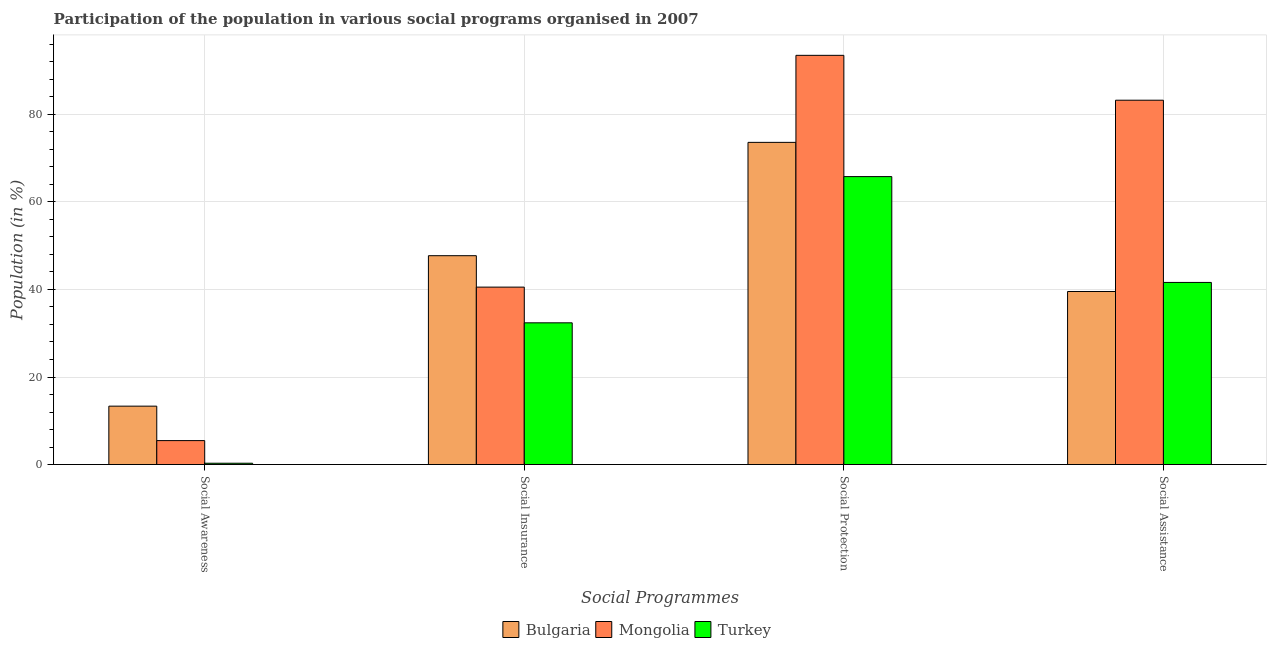How many different coloured bars are there?
Keep it short and to the point. 3. How many groups of bars are there?
Offer a very short reply. 4. Are the number of bars per tick equal to the number of legend labels?
Make the answer very short. Yes. Are the number of bars on each tick of the X-axis equal?
Provide a short and direct response. Yes. How many bars are there on the 2nd tick from the left?
Offer a terse response. 3. What is the label of the 1st group of bars from the left?
Your answer should be compact. Social Awareness. What is the participation of population in social awareness programs in Mongolia?
Ensure brevity in your answer.  5.47. Across all countries, what is the maximum participation of population in social protection programs?
Ensure brevity in your answer.  93.49. Across all countries, what is the minimum participation of population in social protection programs?
Keep it short and to the point. 65.79. What is the total participation of population in social protection programs in the graph?
Make the answer very short. 232.89. What is the difference between the participation of population in social assistance programs in Bulgaria and that in Mongolia?
Your answer should be very brief. -43.7. What is the difference between the participation of population in social assistance programs in Bulgaria and the participation of population in social protection programs in Mongolia?
Provide a short and direct response. -53.96. What is the average participation of population in social protection programs per country?
Give a very brief answer. 77.63. What is the difference between the participation of population in social protection programs and participation of population in social insurance programs in Turkey?
Keep it short and to the point. 33.41. In how many countries, is the participation of population in social awareness programs greater than 80 %?
Ensure brevity in your answer.  0. What is the ratio of the participation of population in social awareness programs in Turkey to that in Bulgaria?
Make the answer very short. 0.02. What is the difference between the highest and the second highest participation of population in social insurance programs?
Your answer should be compact. 7.18. What is the difference between the highest and the lowest participation of population in social awareness programs?
Provide a succinct answer. 13.04. Is it the case that in every country, the sum of the participation of population in social assistance programs and participation of population in social protection programs is greater than the sum of participation of population in social insurance programs and participation of population in social awareness programs?
Your answer should be very brief. Yes. What does the 3rd bar from the left in Social Protection represents?
Offer a terse response. Turkey. What does the 2nd bar from the right in Social Protection represents?
Your response must be concise. Mongolia. Is it the case that in every country, the sum of the participation of population in social awareness programs and participation of population in social insurance programs is greater than the participation of population in social protection programs?
Your answer should be compact. No. How many bars are there?
Provide a short and direct response. 12. Are all the bars in the graph horizontal?
Make the answer very short. No. What is the difference between two consecutive major ticks on the Y-axis?
Your response must be concise. 20. Does the graph contain grids?
Make the answer very short. Yes. Where does the legend appear in the graph?
Ensure brevity in your answer.  Bottom center. How are the legend labels stacked?
Offer a very short reply. Horizontal. What is the title of the graph?
Offer a very short reply. Participation of the population in various social programs organised in 2007. What is the label or title of the X-axis?
Keep it short and to the point. Social Programmes. What is the label or title of the Y-axis?
Keep it short and to the point. Population (in %). What is the Population (in %) of Bulgaria in Social Awareness?
Provide a succinct answer. 13.34. What is the Population (in %) in Mongolia in Social Awareness?
Make the answer very short. 5.47. What is the Population (in %) of Turkey in Social Awareness?
Your answer should be compact. 0.3. What is the Population (in %) of Bulgaria in Social Insurance?
Provide a short and direct response. 47.72. What is the Population (in %) of Mongolia in Social Insurance?
Keep it short and to the point. 40.54. What is the Population (in %) in Turkey in Social Insurance?
Make the answer very short. 32.38. What is the Population (in %) of Bulgaria in Social Protection?
Your response must be concise. 73.61. What is the Population (in %) in Mongolia in Social Protection?
Provide a short and direct response. 93.49. What is the Population (in %) of Turkey in Social Protection?
Keep it short and to the point. 65.79. What is the Population (in %) of Bulgaria in Social Assistance?
Provide a succinct answer. 39.53. What is the Population (in %) in Mongolia in Social Assistance?
Keep it short and to the point. 83.24. What is the Population (in %) in Turkey in Social Assistance?
Your response must be concise. 41.61. Across all Social Programmes, what is the maximum Population (in %) in Bulgaria?
Ensure brevity in your answer.  73.61. Across all Social Programmes, what is the maximum Population (in %) of Mongolia?
Your answer should be compact. 93.49. Across all Social Programmes, what is the maximum Population (in %) in Turkey?
Ensure brevity in your answer.  65.79. Across all Social Programmes, what is the minimum Population (in %) of Bulgaria?
Provide a short and direct response. 13.34. Across all Social Programmes, what is the minimum Population (in %) of Mongolia?
Make the answer very short. 5.47. Across all Social Programmes, what is the minimum Population (in %) of Turkey?
Offer a terse response. 0.3. What is the total Population (in %) in Bulgaria in the graph?
Make the answer very short. 174.2. What is the total Population (in %) in Mongolia in the graph?
Give a very brief answer. 222.73. What is the total Population (in %) of Turkey in the graph?
Provide a succinct answer. 140.07. What is the difference between the Population (in %) of Bulgaria in Social Awareness and that in Social Insurance?
Your answer should be compact. -34.38. What is the difference between the Population (in %) in Mongolia in Social Awareness and that in Social Insurance?
Give a very brief answer. -35.07. What is the difference between the Population (in %) in Turkey in Social Awareness and that in Social Insurance?
Offer a terse response. -32.08. What is the difference between the Population (in %) in Bulgaria in Social Awareness and that in Social Protection?
Ensure brevity in your answer.  -60.27. What is the difference between the Population (in %) in Mongolia in Social Awareness and that in Social Protection?
Make the answer very short. -88.02. What is the difference between the Population (in %) of Turkey in Social Awareness and that in Social Protection?
Keep it short and to the point. -65.49. What is the difference between the Population (in %) of Bulgaria in Social Awareness and that in Social Assistance?
Ensure brevity in your answer.  -26.2. What is the difference between the Population (in %) in Mongolia in Social Awareness and that in Social Assistance?
Offer a terse response. -77.77. What is the difference between the Population (in %) in Turkey in Social Awareness and that in Social Assistance?
Ensure brevity in your answer.  -41.3. What is the difference between the Population (in %) of Bulgaria in Social Insurance and that in Social Protection?
Your answer should be compact. -25.89. What is the difference between the Population (in %) in Mongolia in Social Insurance and that in Social Protection?
Offer a very short reply. -52.96. What is the difference between the Population (in %) of Turkey in Social Insurance and that in Social Protection?
Offer a terse response. -33.41. What is the difference between the Population (in %) in Bulgaria in Social Insurance and that in Social Assistance?
Keep it short and to the point. 8.18. What is the difference between the Population (in %) in Mongolia in Social Insurance and that in Social Assistance?
Your answer should be compact. -42.7. What is the difference between the Population (in %) in Turkey in Social Insurance and that in Social Assistance?
Offer a very short reply. -9.23. What is the difference between the Population (in %) of Bulgaria in Social Protection and that in Social Assistance?
Provide a succinct answer. 34.07. What is the difference between the Population (in %) in Mongolia in Social Protection and that in Social Assistance?
Provide a succinct answer. 10.25. What is the difference between the Population (in %) in Turkey in Social Protection and that in Social Assistance?
Provide a short and direct response. 24.18. What is the difference between the Population (in %) of Bulgaria in Social Awareness and the Population (in %) of Mongolia in Social Insurance?
Provide a succinct answer. -27.2. What is the difference between the Population (in %) of Bulgaria in Social Awareness and the Population (in %) of Turkey in Social Insurance?
Your response must be concise. -19.04. What is the difference between the Population (in %) of Mongolia in Social Awareness and the Population (in %) of Turkey in Social Insurance?
Offer a very short reply. -26.91. What is the difference between the Population (in %) of Bulgaria in Social Awareness and the Population (in %) of Mongolia in Social Protection?
Give a very brief answer. -80.15. What is the difference between the Population (in %) in Bulgaria in Social Awareness and the Population (in %) in Turkey in Social Protection?
Ensure brevity in your answer.  -52.45. What is the difference between the Population (in %) of Mongolia in Social Awareness and the Population (in %) of Turkey in Social Protection?
Your response must be concise. -60.32. What is the difference between the Population (in %) in Bulgaria in Social Awareness and the Population (in %) in Mongolia in Social Assistance?
Ensure brevity in your answer.  -69.9. What is the difference between the Population (in %) of Bulgaria in Social Awareness and the Population (in %) of Turkey in Social Assistance?
Make the answer very short. -28.27. What is the difference between the Population (in %) of Mongolia in Social Awareness and the Population (in %) of Turkey in Social Assistance?
Your answer should be very brief. -36.14. What is the difference between the Population (in %) of Bulgaria in Social Insurance and the Population (in %) of Mongolia in Social Protection?
Keep it short and to the point. -45.78. What is the difference between the Population (in %) in Bulgaria in Social Insurance and the Population (in %) in Turkey in Social Protection?
Offer a terse response. -18.07. What is the difference between the Population (in %) in Mongolia in Social Insurance and the Population (in %) in Turkey in Social Protection?
Offer a very short reply. -25.25. What is the difference between the Population (in %) in Bulgaria in Social Insurance and the Population (in %) in Mongolia in Social Assistance?
Keep it short and to the point. -35.52. What is the difference between the Population (in %) in Bulgaria in Social Insurance and the Population (in %) in Turkey in Social Assistance?
Give a very brief answer. 6.11. What is the difference between the Population (in %) of Mongolia in Social Insurance and the Population (in %) of Turkey in Social Assistance?
Provide a short and direct response. -1.07. What is the difference between the Population (in %) of Bulgaria in Social Protection and the Population (in %) of Mongolia in Social Assistance?
Keep it short and to the point. -9.63. What is the difference between the Population (in %) in Bulgaria in Social Protection and the Population (in %) in Turkey in Social Assistance?
Keep it short and to the point. 32. What is the difference between the Population (in %) of Mongolia in Social Protection and the Population (in %) of Turkey in Social Assistance?
Your response must be concise. 51.89. What is the average Population (in %) in Bulgaria per Social Programmes?
Offer a very short reply. 43.55. What is the average Population (in %) of Mongolia per Social Programmes?
Give a very brief answer. 55.68. What is the average Population (in %) in Turkey per Social Programmes?
Offer a very short reply. 35.02. What is the difference between the Population (in %) in Bulgaria and Population (in %) in Mongolia in Social Awareness?
Make the answer very short. 7.87. What is the difference between the Population (in %) in Bulgaria and Population (in %) in Turkey in Social Awareness?
Your answer should be compact. 13.04. What is the difference between the Population (in %) in Mongolia and Population (in %) in Turkey in Social Awareness?
Give a very brief answer. 5.17. What is the difference between the Population (in %) of Bulgaria and Population (in %) of Mongolia in Social Insurance?
Offer a terse response. 7.18. What is the difference between the Population (in %) of Bulgaria and Population (in %) of Turkey in Social Insurance?
Your answer should be very brief. 15.34. What is the difference between the Population (in %) of Mongolia and Population (in %) of Turkey in Social Insurance?
Offer a very short reply. 8.16. What is the difference between the Population (in %) in Bulgaria and Population (in %) in Mongolia in Social Protection?
Provide a short and direct response. -19.88. What is the difference between the Population (in %) in Bulgaria and Population (in %) in Turkey in Social Protection?
Give a very brief answer. 7.82. What is the difference between the Population (in %) of Mongolia and Population (in %) of Turkey in Social Protection?
Your answer should be very brief. 27.7. What is the difference between the Population (in %) of Bulgaria and Population (in %) of Mongolia in Social Assistance?
Keep it short and to the point. -43.7. What is the difference between the Population (in %) in Bulgaria and Population (in %) in Turkey in Social Assistance?
Ensure brevity in your answer.  -2.07. What is the difference between the Population (in %) of Mongolia and Population (in %) of Turkey in Social Assistance?
Offer a terse response. 41.63. What is the ratio of the Population (in %) in Bulgaria in Social Awareness to that in Social Insurance?
Provide a succinct answer. 0.28. What is the ratio of the Population (in %) in Mongolia in Social Awareness to that in Social Insurance?
Your answer should be compact. 0.13. What is the ratio of the Population (in %) in Turkey in Social Awareness to that in Social Insurance?
Provide a succinct answer. 0.01. What is the ratio of the Population (in %) of Bulgaria in Social Awareness to that in Social Protection?
Ensure brevity in your answer.  0.18. What is the ratio of the Population (in %) of Mongolia in Social Awareness to that in Social Protection?
Your answer should be compact. 0.06. What is the ratio of the Population (in %) of Turkey in Social Awareness to that in Social Protection?
Provide a short and direct response. 0. What is the ratio of the Population (in %) in Bulgaria in Social Awareness to that in Social Assistance?
Your response must be concise. 0.34. What is the ratio of the Population (in %) of Mongolia in Social Awareness to that in Social Assistance?
Provide a succinct answer. 0.07. What is the ratio of the Population (in %) of Turkey in Social Awareness to that in Social Assistance?
Offer a very short reply. 0.01. What is the ratio of the Population (in %) of Bulgaria in Social Insurance to that in Social Protection?
Keep it short and to the point. 0.65. What is the ratio of the Population (in %) in Mongolia in Social Insurance to that in Social Protection?
Give a very brief answer. 0.43. What is the ratio of the Population (in %) of Turkey in Social Insurance to that in Social Protection?
Your answer should be very brief. 0.49. What is the ratio of the Population (in %) in Bulgaria in Social Insurance to that in Social Assistance?
Offer a terse response. 1.21. What is the ratio of the Population (in %) of Mongolia in Social Insurance to that in Social Assistance?
Your response must be concise. 0.49. What is the ratio of the Population (in %) of Turkey in Social Insurance to that in Social Assistance?
Your answer should be compact. 0.78. What is the ratio of the Population (in %) in Bulgaria in Social Protection to that in Social Assistance?
Your response must be concise. 1.86. What is the ratio of the Population (in %) of Mongolia in Social Protection to that in Social Assistance?
Keep it short and to the point. 1.12. What is the ratio of the Population (in %) in Turkey in Social Protection to that in Social Assistance?
Your answer should be very brief. 1.58. What is the difference between the highest and the second highest Population (in %) of Bulgaria?
Make the answer very short. 25.89. What is the difference between the highest and the second highest Population (in %) of Mongolia?
Give a very brief answer. 10.25. What is the difference between the highest and the second highest Population (in %) in Turkey?
Provide a succinct answer. 24.18. What is the difference between the highest and the lowest Population (in %) in Bulgaria?
Your answer should be very brief. 60.27. What is the difference between the highest and the lowest Population (in %) in Mongolia?
Ensure brevity in your answer.  88.02. What is the difference between the highest and the lowest Population (in %) of Turkey?
Keep it short and to the point. 65.49. 